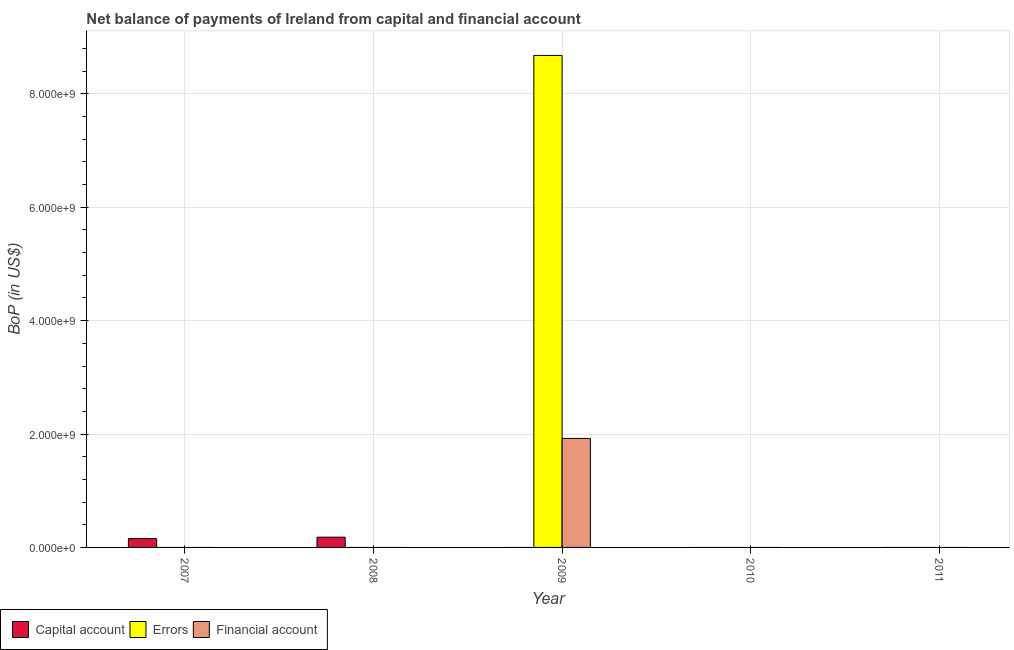Are the number of bars per tick equal to the number of legend labels?
Your answer should be very brief. No. What is the label of the 5th group of bars from the left?
Keep it short and to the point. 2011. In how many cases, is the number of bars for a given year not equal to the number of legend labels?
Keep it short and to the point. 5. Across all years, what is the maximum amount of errors?
Make the answer very short. 8.68e+09. Across all years, what is the minimum amount of errors?
Your answer should be compact. 0. In which year was the amount of financial account maximum?
Your answer should be compact. 2009. What is the total amount of errors in the graph?
Ensure brevity in your answer.  8.68e+09. What is the difference between the amount of net capital account in 2007 and that in 2008?
Make the answer very short. -2.53e+07. What is the difference between the amount of net capital account in 2011 and the amount of errors in 2008?
Your answer should be very brief. -1.80e+08. What is the average amount of financial account per year?
Keep it short and to the point. 3.84e+08. What is the ratio of the amount of net capital account in 2007 to that in 2008?
Keep it short and to the point. 0.86. What is the difference between the highest and the lowest amount of financial account?
Offer a very short reply. 1.92e+09. How many years are there in the graph?
Offer a very short reply. 5. What is the difference between two consecutive major ticks on the Y-axis?
Provide a short and direct response. 2.00e+09. Are the values on the major ticks of Y-axis written in scientific E-notation?
Give a very brief answer. Yes. What is the title of the graph?
Keep it short and to the point. Net balance of payments of Ireland from capital and financial account. Does "Communicable diseases" appear as one of the legend labels in the graph?
Your response must be concise. No. What is the label or title of the Y-axis?
Ensure brevity in your answer.  BoP (in US$). What is the BoP (in US$) in Capital account in 2007?
Offer a very short reply. 1.55e+08. What is the BoP (in US$) of Errors in 2007?
Offer a very short reply. 0. What is the BoP (in US$) of Financial account in 2007?
Your response must be concise. 0. What is the BoP (in US$) in Capital account in 2008?
Offer a very short reply. 1.80e+08. What is the BoP (in US$) of Errors in 2008?
Provide a succinct answer. 0. What is the BoP (in US$) of Financial account in 2008?
Your answer should be compact. 0. What is the BoP (in US$) in Capital account in 2009?
Your answer should be compact. 0. What is the BoP (in US$) of Errors in 2009?
Provide a succinct answer. 8.68e+09. What is the BoP (in US$) in Financial account in 2009?
Provide a short and direct response. 1.92e+09. What is the BoP (in US$) in Capital account in 2010?
Ensure brevity in your answer.  0. What is the BoP (in US$) of Errors in 2010?
Give a very brief answer. 0. What is the BoP (in US$) of Financial account in 2010?
Your response must be concise. 0. What is the BoP (in US$) in Financial account in 2011?
Make the answer very short. 0. Across all years, what is the maximum BoP (in US$) in Capital account?
Keep it short and to the point. 1.80e+08. Across all years, what is the maximum BoP (in US$) of Errors?
Provide a succinct answer. 8.68e+09. Across all years, what is the maximum BoP (in US$) in Financial account?
Provide a short and direct response. 1.92e+09. Across all years, what is the minimum BoP (in US$) of Capital account?
Your answer should be compact. 0. What is the total BoP (in US$) in Capital account in the graph?
Your answer should be very brief. 3.36e+08. What is the total BoP (in US$) of Errors in the graph?
Provide a short and direct response. 8.68e+09. What is the total BoP (in US$) of Financial account in the graph?
Your answer should be very brief. 1.92e+09. What is the difference between the BoP (in US$) in Capital account in 2007 and that in 2008?
Provide a short and direct response. -2.53e+07. What is the difference between the BoP (in US$) of Capital account in 2007 and the BoP (in US$) of Errors in 2009?
Keep it short and to the point. -8.52e+09. What is the difference between the BoP (in US$) of Capital account in 2007 and the BoP (in US$) of Financial account in 2009?
Provide a succinct answer. -1.77e+09. What is the difference between the BoP (in US$) in Capital account in 2008 and the BoP (in US$) in Errors in 2009?
Ensure brevity in your answer.  -8.50e+09. What is the difference between the BoP (in US$) of Capital account in 2008 and the BoP (in US$) of Financial account in 2009?
Offer a very short reply. -1.74e+09. What is the average BoP (in US$) of Capital account per year?
Provide a short and direct response. 6.71e+07. What is the average BoP (in US$) in Errors per year?
Make the answer very short. 1.74e+09. What is the average BoP (in US$) of Financial account per year?
Your answer should be very brief. 3.84e+08. In the year 2009, what is the difference between the BoP (in US$) in Errors and BoP (in US$) in Financial account?
Offer a very short reply. 6.76e+09. What is the ratio of the BoP (in US$) of Capital account in 2007 to that in 2008?
Ensure brevity in your answer.  0.86. What is the difference between the highest and the lowest BoP (in US$) of Capital account?
Offer a terse response. 1.80e+08. What is the difference between the highest and the lowest BoP (in US$) in Errors?
Your answer should be compact. 8.68e+09. What is the difference between the highest and the lowest BoP (in US$) in Financial account?
Give a very brief answer. 1.92e+09. 